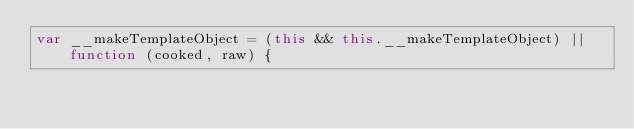Convert code to text. <code><loc_0><loc_0><loc_500><loc_500><_JavaScript_>var __makeTemplateObject = (this && this.__makeTemplateObject) || function (cooked, raw) {</code> 